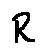Convert formula to latex. <formula><loc_0><loc_0><loc_500><loc_500>R</formula> 